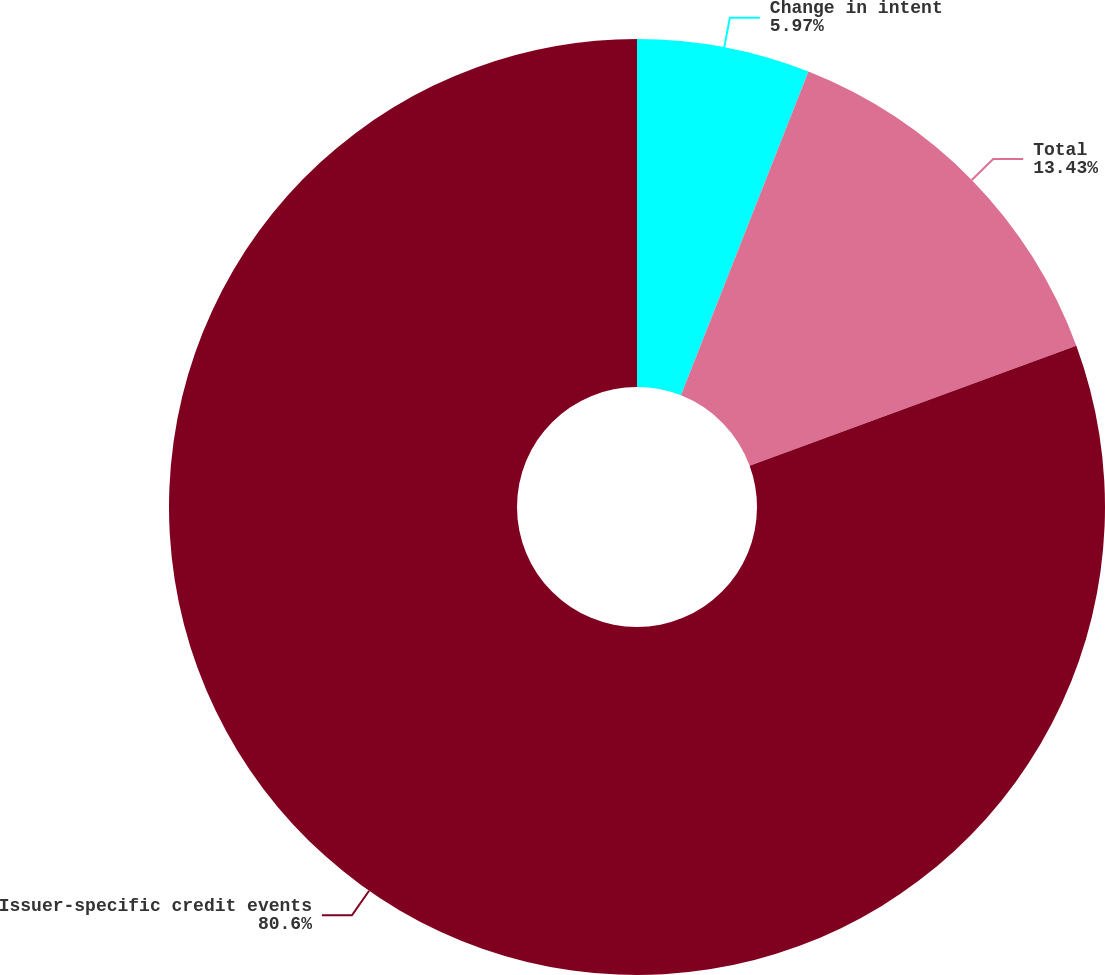Convert chart. <chart><loc_0><loc_0><loc_500><loc_500><pie_chart><fcel>Change in intent<fcel>Total<fcel>Issuer-specific credit events<nl><fcel>5.97%<fcel>13.43%<fcel>80.6%<nl></chart> 